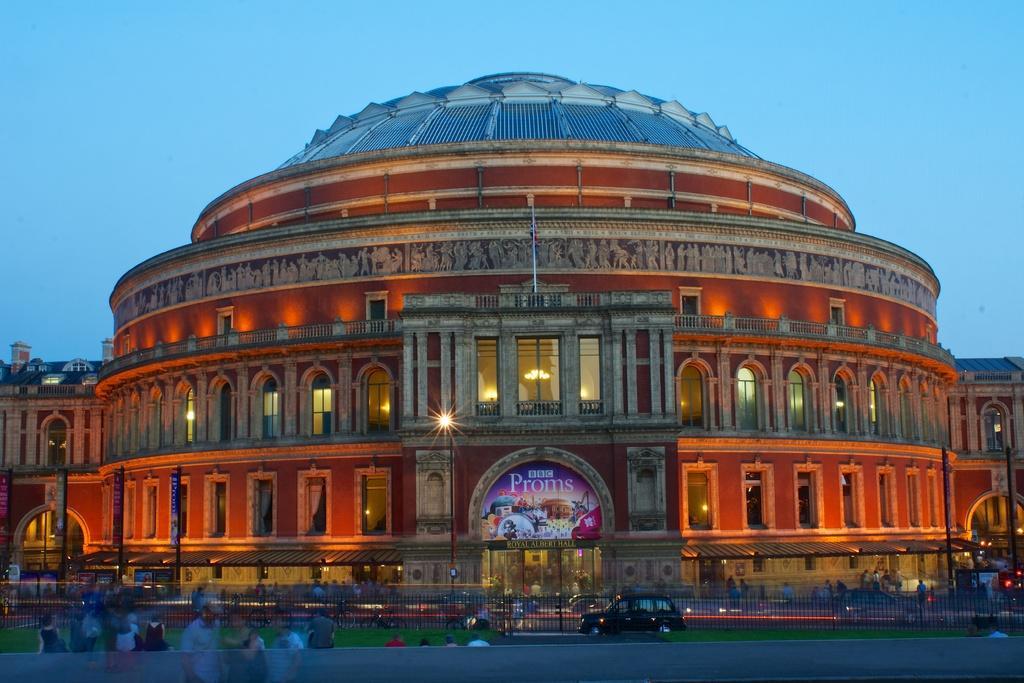Could you give a brief overview of what you see in this image? In this image we can see a building, there are some poles, boards, lights, windows, grass, people, vehicles and fence, in the background, we can see the sky. 